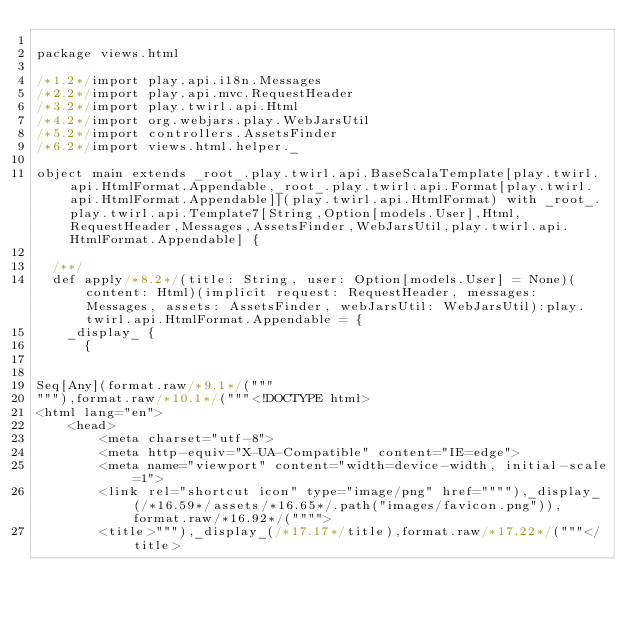Convert code to text. <code><loc_0><loc_0><loc_500><loc_500><_Scala_>
package views.html

/*1.2*/import play.api.i18n.Messages
/*2.2*/import play.api.mvc.RequestHeader
/*3.2*/import play.twirl.api.Html
/*4.2*/import org.webjars.play.WebJarsUtil
/*5.2*/import controllers.AssetsFinder
/*6.2*/import views.html.helper._

object main extends _root_.play.twirl.api.BaseScalaTemplate[play.twirl.api.HtmlFormat.Appendable,_root_.play.twirl.api.Format[play.twirl.api.HtmlFormat.Appendable]](play.twirl.api.HtmlFormat) with _root_.play.twirl.api.Template7[String,Option[models.User],Html,RequestHeader,Messages,AssetsFinder,WebJarsUtil,play.twirl.api.HtmlFormat.Appendable] {

  /**/
  def apply/*8.2*/(title: String, user: Option[models.User] = None)(content: Html)(implicit request: RequestHeader, messages: Messages, assets: AssetsFinder, webJarsUtil: WebJarsUtil):play.twirl.api.HtmlFormat.Appendable = {
    _display_ {
      {


Seq[Any](format.raw/*9.1*/("""
"""),format.raw/*10.1*/("""<!DOCTYPE html>
<html lang="en">
    <head>
        <meta charset="utf-8">
        <meta http-equiv="X-UA-Compatible" content="IE=edge">
        <meta name="viewport" content="width=device-width, initial-scale=1">
        <link rel="shortcut icon" type="image/png" href=""""),_display_(/*16.59*/assets/*16.65*/.path("images/favicon.png")),format.raw/*16.92*/("""">
        <title>"""),_display_(/*17.17*/title),format.raw/*17.22*/("""</title></code> 